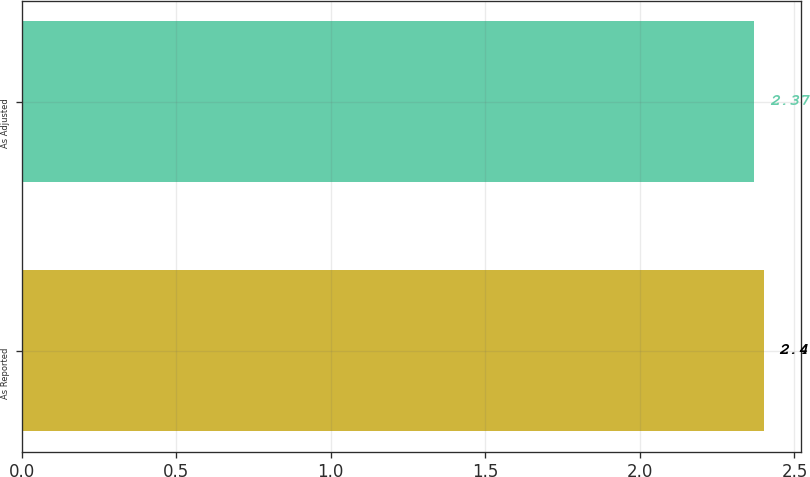Convert chart. <chart><loc_0><loc_0><loc_500><loc_500><bar_chart><fcel>As Reported<fcel>As Adjusted<nl><fcel>2.4<fcel>2.37<nl></chart> 